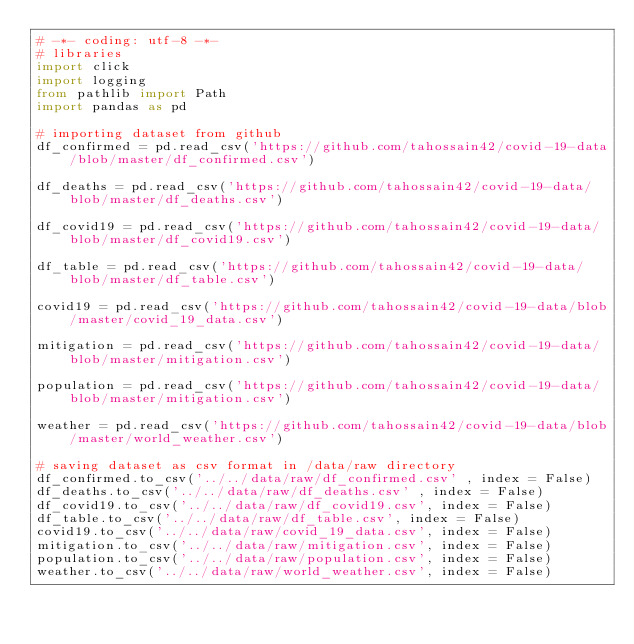<code> <loc_0><loc_0><loc_500><loc_500><_Python_># -*- coding: utf-8 -*-
# libraries
import click
import logging
from pathlib import Path
import pandas as pd

# importing dataset from github
df_confirmed = pd.read_csv('https://github.com/tahossain42/covid-19-data/blob/master/df_confirmed.csv')

df_deaths = pd.read_csv('https://github.com/tahossain42/covid-19-data/blob/master/df_deaths.csv')

df_covid19 = pd.read_csv('https://github.com/tahossain42/covid-19-data/blob/master/df_covid19.csv')

df_table = pd.read_csv('https://github.com/tahossain42/covid-19-data/blob/master/df_table.csv')

covid19 = pd.read_csv('https://github.com/tahossain42/covid-19-data/blob/master/covid_19_data.csv')

mitigation = pd.read_csv('https://github.com/tahossain42/covid-19-data/blob/master/mitigation.csv')

population = pd.read_csv('https://github.com/tahossain42/covid-19-data/blob/master/mitigation.csv')

weather = pd.read_csv('https://github.com/tahossain42/covid-19-data/blob/master/world_weather.csv')

# saving dataset as csv format in /data/raw directory 
df_confirmed.to_csv('../../data/raw/df_confirmed.csv' , index = False)
df_deaths.to_csv('../../data/raw/df_deaths.csv' , index = False)
df_covid19.to_csv('../../data/raw/df_covid19.csv', index = False)
df_table.to_csv('../../data/raw/df_table.csv', index = False)
covid19.to_csv('../../data/raw/covid_19_data.csv', index = False)
mitigation.to_csv('../../data/raw/mitigation.csv', index = False)
population.to_csv('../../data/raw/population.csv', index = False)
weather.to_csv('../../data/raw/world_weather.csv', index = False)
</code> 